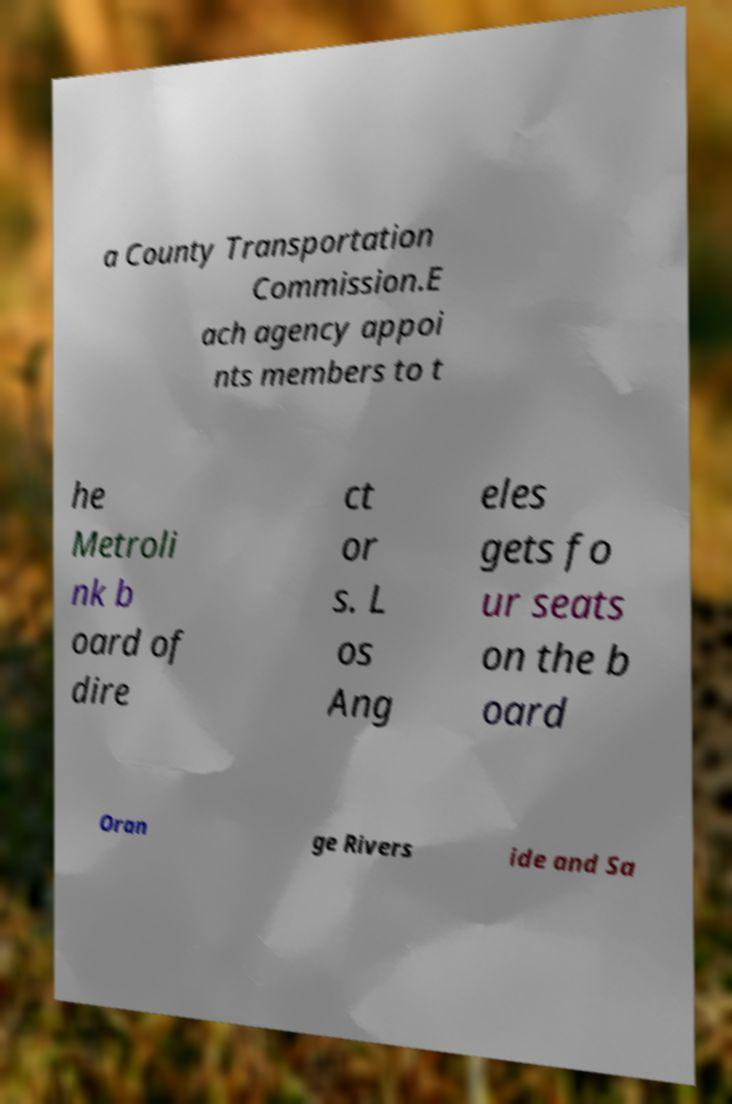There's text embedded in this image that I need extracted. Can you transcribe it verbatim? a County Transportation Commission.E ach agency appoi nts members to t he Metroli nk b oard of dire ct or s. L os Ang eles gets fo ur seats on the b oard Oran ge Rivers ide and Sa 